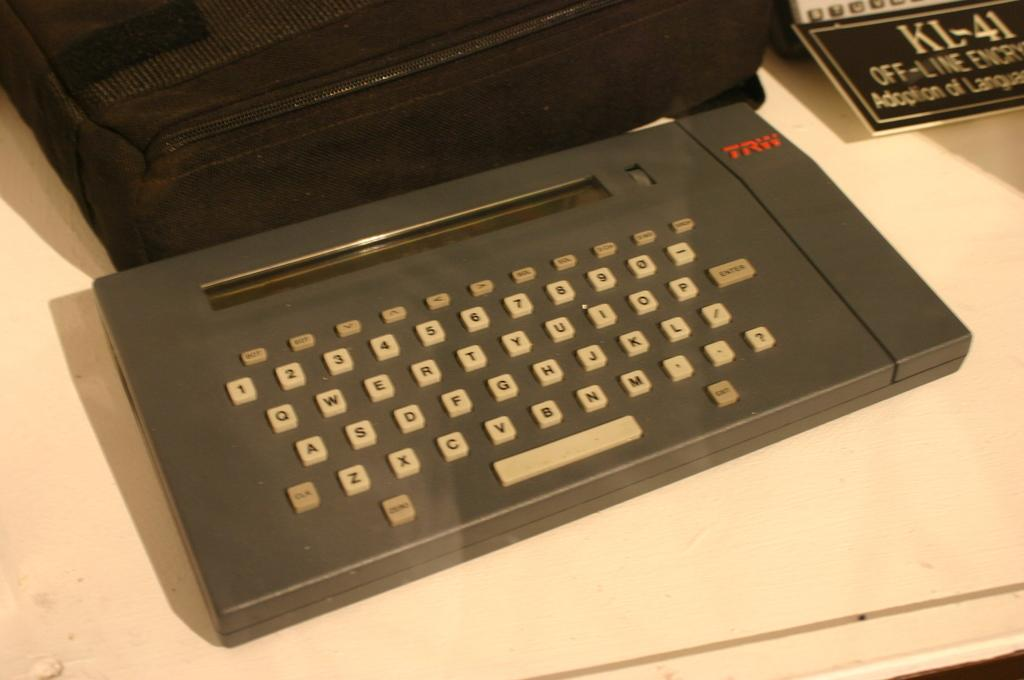<image>
Offer a succinct explanation of the picture presented. Black keypad that has the letters TRW in red on the top. 